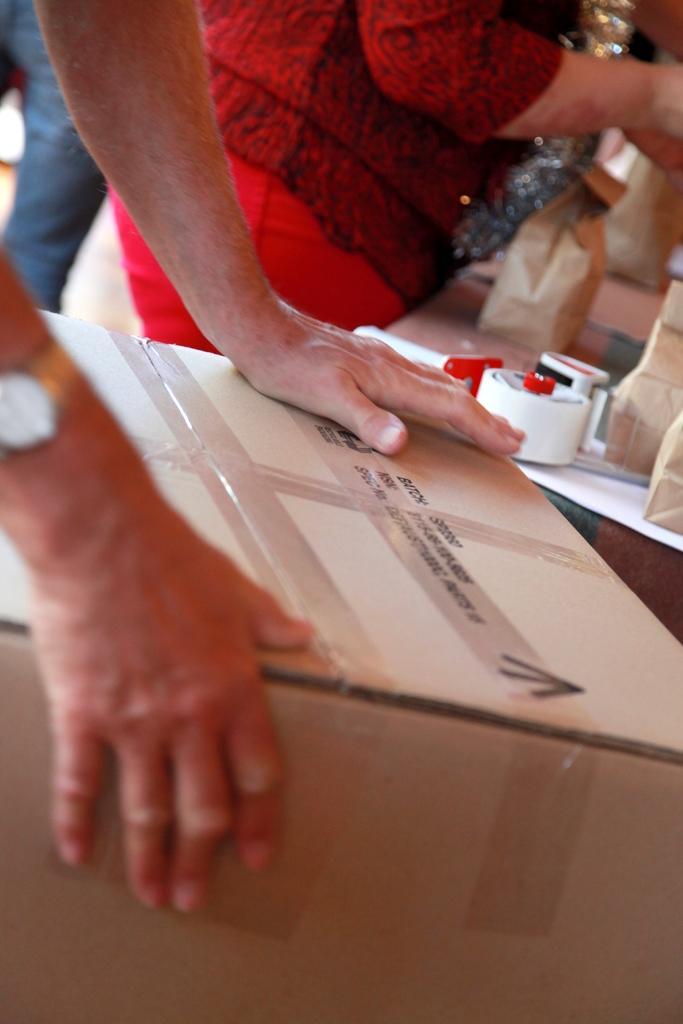Describe this image in one or two sentences. In this image we can see the hand of a person holding a cardboard box. On the backside we can see a woman standing near a table containing some paper bags and plasters on it. 